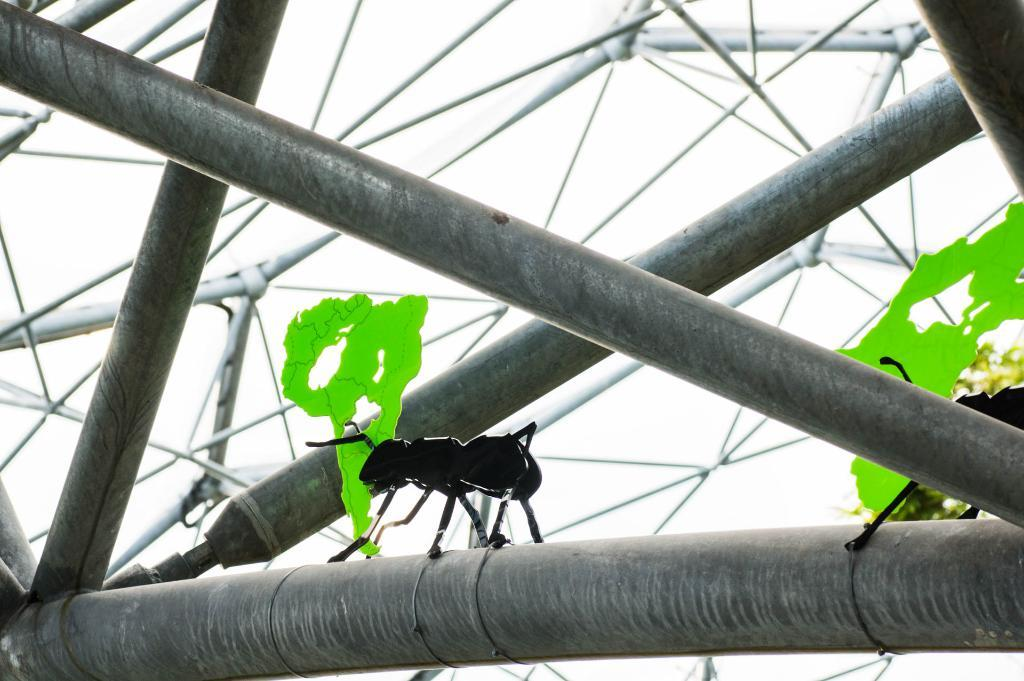What objects can be seen in the image? There are rods in the image. Are there any living organisms present on the rods? Yes, there are two black ants on one of the rods. How many pigs are visible in the image? There are no pigs present in the image. What type of kettle is being used by the ants in the image? There is no kettle present in the image, and the ants are not using any tools or objects. 